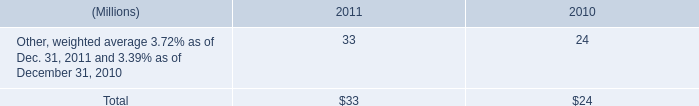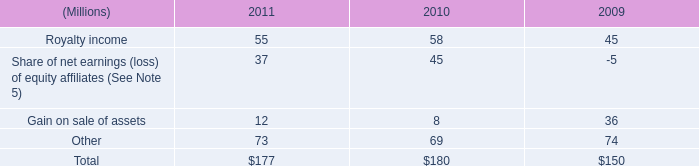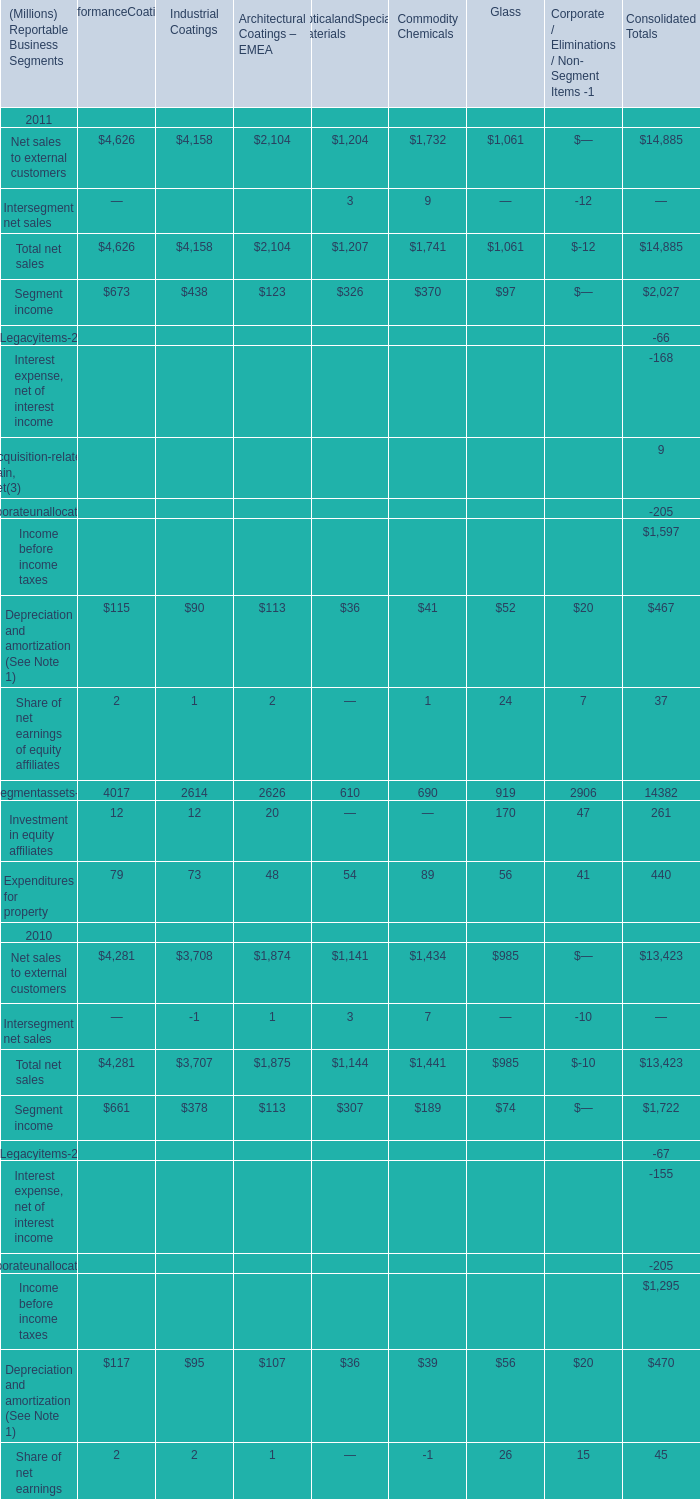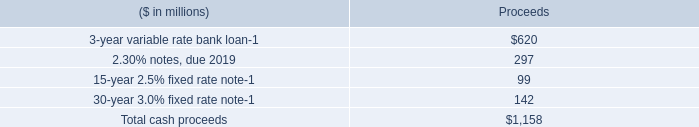what would the remaining cost to repurchase shares under the october 2009 agreement be assuming the december 31 , 2009 weighted average share price ? 
Computations: (((1.2 - 1.1) * 1000000) * 56.66)
Answer: 5666000.0. 